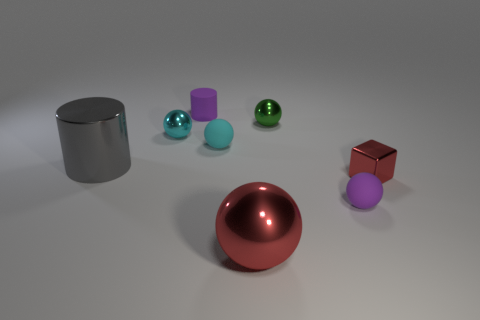Subtract all cyan blocks. Subtract all cyan spheres. How many blocks are left? 1 Subtract all yellow cylinders. How many brown blocks are left? 0 Add 7 cyans. How many tiny reds exist? 0 Subtract all large red spheres. Subtract all small cyan matte things. How many objects are left? 6 Add 7 small green metal things. How many small green metal things are left? 8 Add 2 tiny purple matte balls. How many tiny purple matte balls exist? 3 Add 2 large blue cubes. How many objects exist? 10 Subtract all purple cylinders. How many cylinders are left? 1 Subtract all tiny spheres. How many spheres are left? 1 Subtract 0 cyan blocks. How many objects are left? 8 